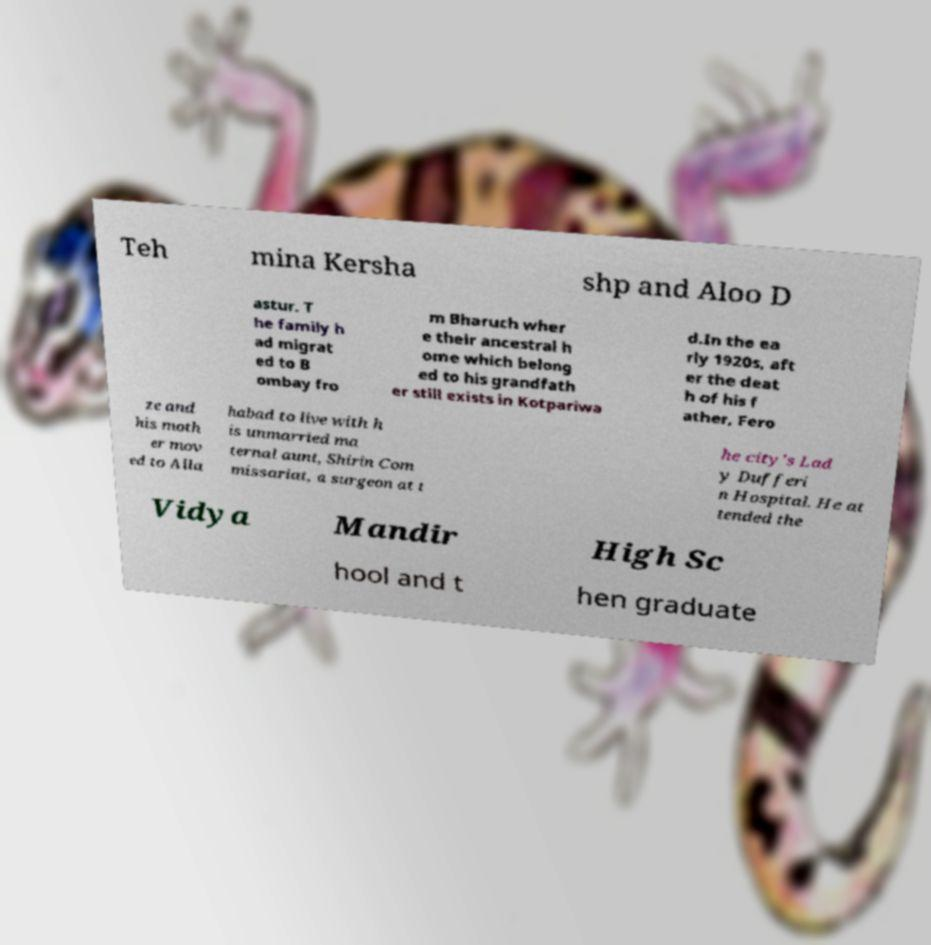Could you assist in decoding the text presented in this image and type it out clearly? Teh mina Kersha shp and Aloo D astur. T he family h ad migrat ed to B ombay fro m Bharuch wher e their ancestral h ome which belong ed to his grandfath er still exists in Kotpariwa d.In the ea rly 1920s, aft er the deat h of his f ather, Fero ze and his moth er mov ed to Alla habad to live with h is unmarried ma ternal aunt, Shirin Com missariat, a surgeon at t he city's Lad y Dufferi n Hospital. He at tended the Vidya Mandir High Sc hool and t hen graduate 